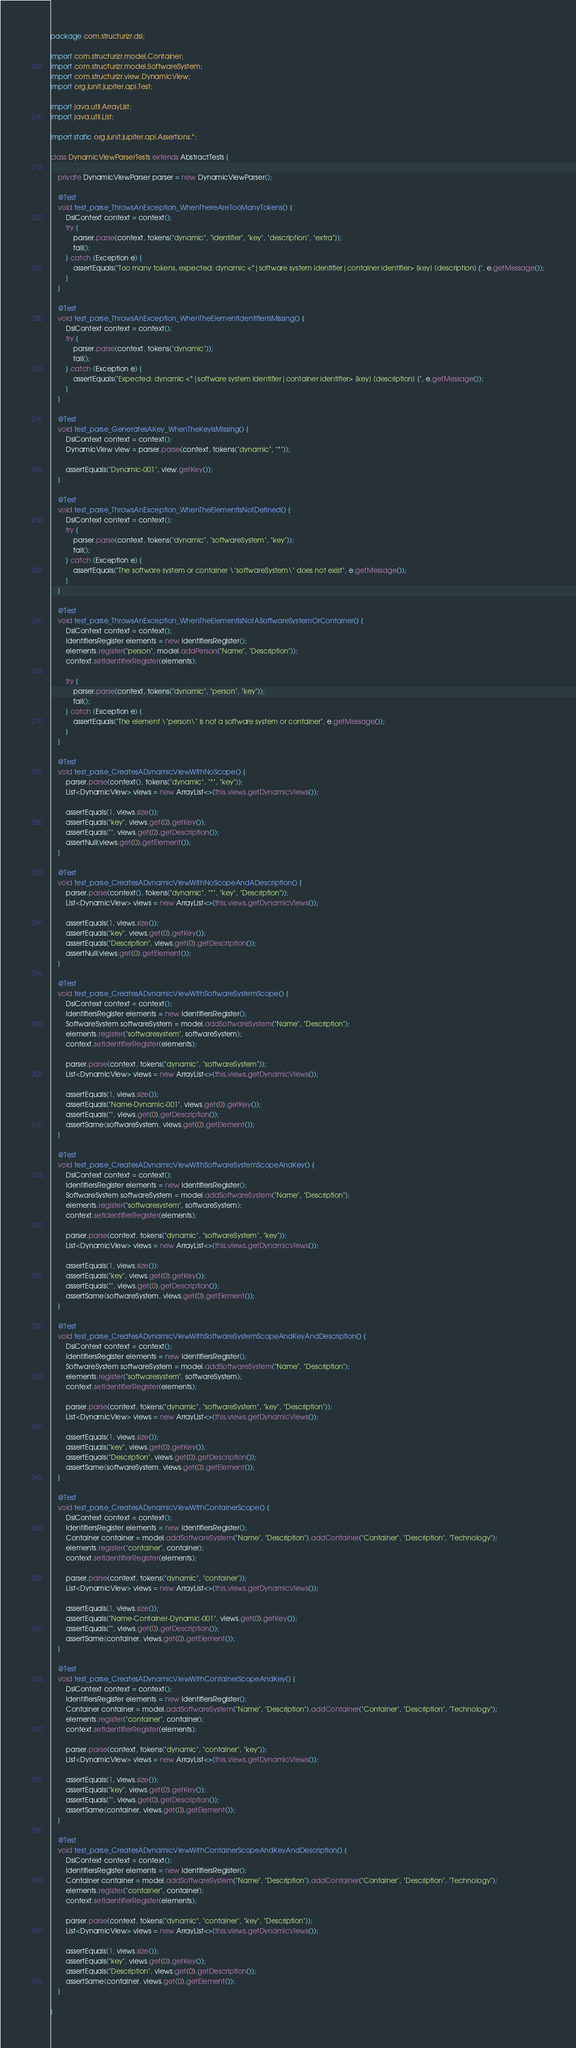<code> <loc_0><loc_0><loc_500><loc_500><_Java_>package com.structurizr.dsl;

import com.structurizr.model.Container;
import com.structurizr.model.SoftwareSystem;
import com.structurizr.view.DynamicView;
import org.junit.jupiter.api.Test;

import java.util.ArrayList;
import java.util.List;

import static org.junit.jupiter.api.Assertions.*;

class DynamicViewParserTests extends AbstractTests {

    private DynamicViewParser parser = new DynamicViewParser();

    @Test
    void test_parse_ThrowsAnException_WhenThereAreTooManyTokens() {
        DslContext context = context();
        try {
            parser.parse(context, tokens("dynamic", "identifier", "key", "description", "extra"));
            fail();
        } catch (Exception e) {
            assertEquals("Too many tokens, expected: dynamic <*|software system identifier|container identifier> [key] [description] {", e.getMessage());
        }
    }

    @Test
    void test_parse_ThrowsAnException_WhenTheElementIdentifierIsMissing() {
        DslContext context = context();
        try {
            parser.parse(context, tokens("dynamic"));
            fail();
        } catch (Exception e) {
            assertEquals("Expected: dynamic <*|software system identifier|container identifier> [key] [description] {", e.getMessage());
        }
    }

    @Test
    void test_parse_GeneratesAKey_WhenTheKeyIsMissing() {
        DslContext context = context();
        DynamicView view = parser.parse(context, tokens("dynamic", "*"));

        assertEquals("Dynamic-001", view.getKey());
    }

    @Test
    void test_parse_ThrowsAnException_WhenTheElementIsNotDefined() {
        DslContext context = context();
        try {
            parser.parse(context, tokens("dynamic", "softwareSystem", "key"));
            fail();
        } catch (Exception e) {
            assertEquals("The software system or container \"softwareSystem\" does not exist", e.getMessage());
        }
    }

    @Test
    void test_parse_ThrowsAnException_WhenTheElementIsNotASoftwareSystemOrContainer() {
        DslContext context = context();
        IdentifiersRegister elements = new IdentifiersRegister();
        elements.register("person", model.addPerson("Name", "Description"));
        context.setIdentifierRegister(elements);

        try {
            parser.parse(context, tokens("dynamic", "person", "key"));
            fail();
        } catch (Exception e) {
            assertEquals("The element \"person\" is not a software system or container", e.getMessage());
        }
    }

    @Test
    void test_parse_CreatesADynamicViewWithNoScope() {
        parser.parse(context(), tokens("dynamic", "*", "key"));
        List<DynamicView> views = new ArrayList<>(this.views.getDynamicViews());

        assertEquals(1, views.size());
        assertEquals("key", views.get(0).getKey());
        assertEquals("", views.get(0).getDescription());
        assertNull(views.get(0).getElement());
    }

    @Test
    void test_parse_CreatesADynamicViewWithNoScopeAndADescription() {
        parser.parse(context(), tokens("dynamic", "*", "key", "Description"));
        List<DynamicView> views = new ArrayList<>(this.views.getDynamicViews());

        assertEquals(1, views.size());
        assertEquals("key", views.get(0).getKey());
        assertEquals("Description", views.get(0).getDescription());
        assertNull(views.get(0).getElement());
    }

    @Test
    void test_parse_CreatesADynamicViewWithSoftwareSystemScope() {
        DslContext context = context();
        IdentifiersRegister elements = new IdentifiersRegister();
        SoftwareSystem softwareSystem = model.addSoftwareSystem("Name", "Description");
        elements.register("softwaresystem", softwareSystem);
        context.setIdentifierRegister(elements);

        parser.parse(context, tokens("dynamic", "softwareSystem"));
        List<DynamicView> views = new ArrayList<>(this.views.getDynamicViews());

        assertEquals(1, views.size());
        assertEquals("Name-Dynamic-001", views.get(0).getKey());
        assertEquals("", views.get(0).getDescription());
        assertSame(softwareSystem, views.get(0).getElement());
    }

    @Test
    void test_parse_CreatesADynamicViewWithSoftwareSystemScopeAndKey() {
        DslContext context = context();
        IdentifiersRegister elements = new IdentifiersRegister();
        SoftwareSystem softwareSystem = model.addSoftwareSystem("Name", "Description");
        elements.register("softwaresystem", softwareSystem);
        context.setIdentifierRegister(elements);

        parser.parse(context, tokens("dynamic", "softwareSystem", "key"));
        List<DynamicView> views = new ArrayList<>(this.views.getDynamicViews());

        assertEquals(1, views.size());
        assertEquals("key", views.get(0).getKey());
        assertEquals("", views.get(0).getDescription());
        assertSame(softwareSystem, views.get(0).getElement());
    }

    @Test
    void test_parse_CreatesADynamicViewWithSoftwareSystemScopeAndKeyAndDescription() {
        DslContext context = context();
        IdentifiersRegister elements = new IdentifiersRegister();
        SoftwareSystem softwareSystem = model.addSoftwareSystem("Name", "Description");
        elements.register("softwaresystem", softwareSystem);
        context.setIdentifierRegister(elements);

        parser.parse(context, tokens("dynamic", "softwareSystem", "key", "Description"));
        List<DynamicView> views = new ArrayList<>(this.views.getDynamicViews());

        assertEquals(1, views.size());
        assertEquals("key", views.get(0).getKey());
        assertEquals("Description", views.get(0).getDescription());
        assertSame(softwareSystem, views.get(0).getElement());
    }

    @Test
    void test_parse_CreatesADynamicViewWithContainerScope() {
        DslContext context = context();
        IdentifiersRegister elements = new IdentifiersRegister();
        Container container = model.addSoftwareSystem("Name", "Description").addContainer("Container", "Description", "Technology");
        elements.register("container", container);
        context.setIdentifierRegister(elements);

        parser.parse(context, tokens("dynamic", "container"));
        List<DynamicView> views = new ArrayList<>(this.views.getDynamicViews());

        assertEquals(1, views.size());
        assertEquals("Name-Container-Dynamic-001", views.get(0).getKey());
        assertEquals("", views.get(0).getDescription());
        assertSame(container, views.get(0).getElement());
    }

    @Test
    void test_parse_CreatesADynamicViewWithContainerScopeAndKey() {
        DslContext context = context();
        IdentifiersRegister elements = new IdentifiersRegister();
        Container container = model.addSoftwareSystem("Name", "Description").addContainer("Container", "Description", "Technology");
        elements.register("container", container);
        context.setIdentifierRegister(elements);

        parser.parse(context, tokens("dynamic", "container", "key"));
        List<DynamicView> views = new ArrayList<>(this.views.getDynamicViews());

        assertEquals(1, views.size());
        assertEquals("key", views.get(0).getKey());
        assertEquals("", views.get(0).getDescription());
        assertSame(container, views.get(0).getElement());
    }

    @Test
    void test_parse_CreatesADynamicViewWithContainerScopeAndKeyAndDescription() {
        DslContext context = context();
        IdentifiersRegister elements = new IdentifiersRegister();
        Container container = model.addSoftwareSystem("Name", "Description").addContainer("Container", "Description", "Technology");
        elements.register("container", container);
        context.setIdentifierRegister(elements);

        parser.parse(context, tokens("dynamic", "container", "key", "Description"));
        List<DynamicView> views = new ArrayList<>(this.views.getDynamicViews());

        assertEquals(1, views.size());
        assertEquals("key", views.get(0).getKey());
        assertEquals("Description", views.get(0).getDescription());
        assertSame(container, views.get(0).getElement());
    }

}</code> 